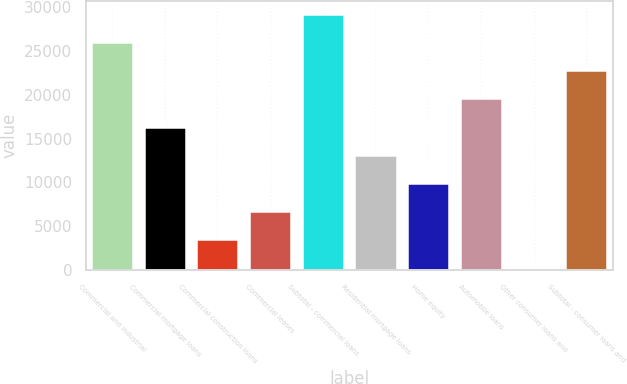Convert chart. <chart><loc_0><loc_0><loc_500><loc_500><bar_chart><fcel>Commercial and industrial<fcel>Commercial mortgage loans<fcel>Commercial construction loans<fcel>Commercial leases<fcel>Subtotal - commercial loans<fcel>Residential mortgage loans<fcel>Home equity<fcel>Automobile loans<fcel>Other consumer loans and<fcel>Subtotal - consumer loans and<nl><fcel>25972<fcel>16349.5<fcel>3519.5<fcel>6727<fcel>29179.5<fcel>13142<fcel>9934.5<fcel>19557<fcel>312<fcel>22764.5<nl></chart> 